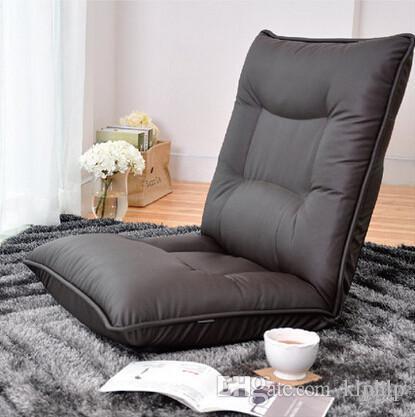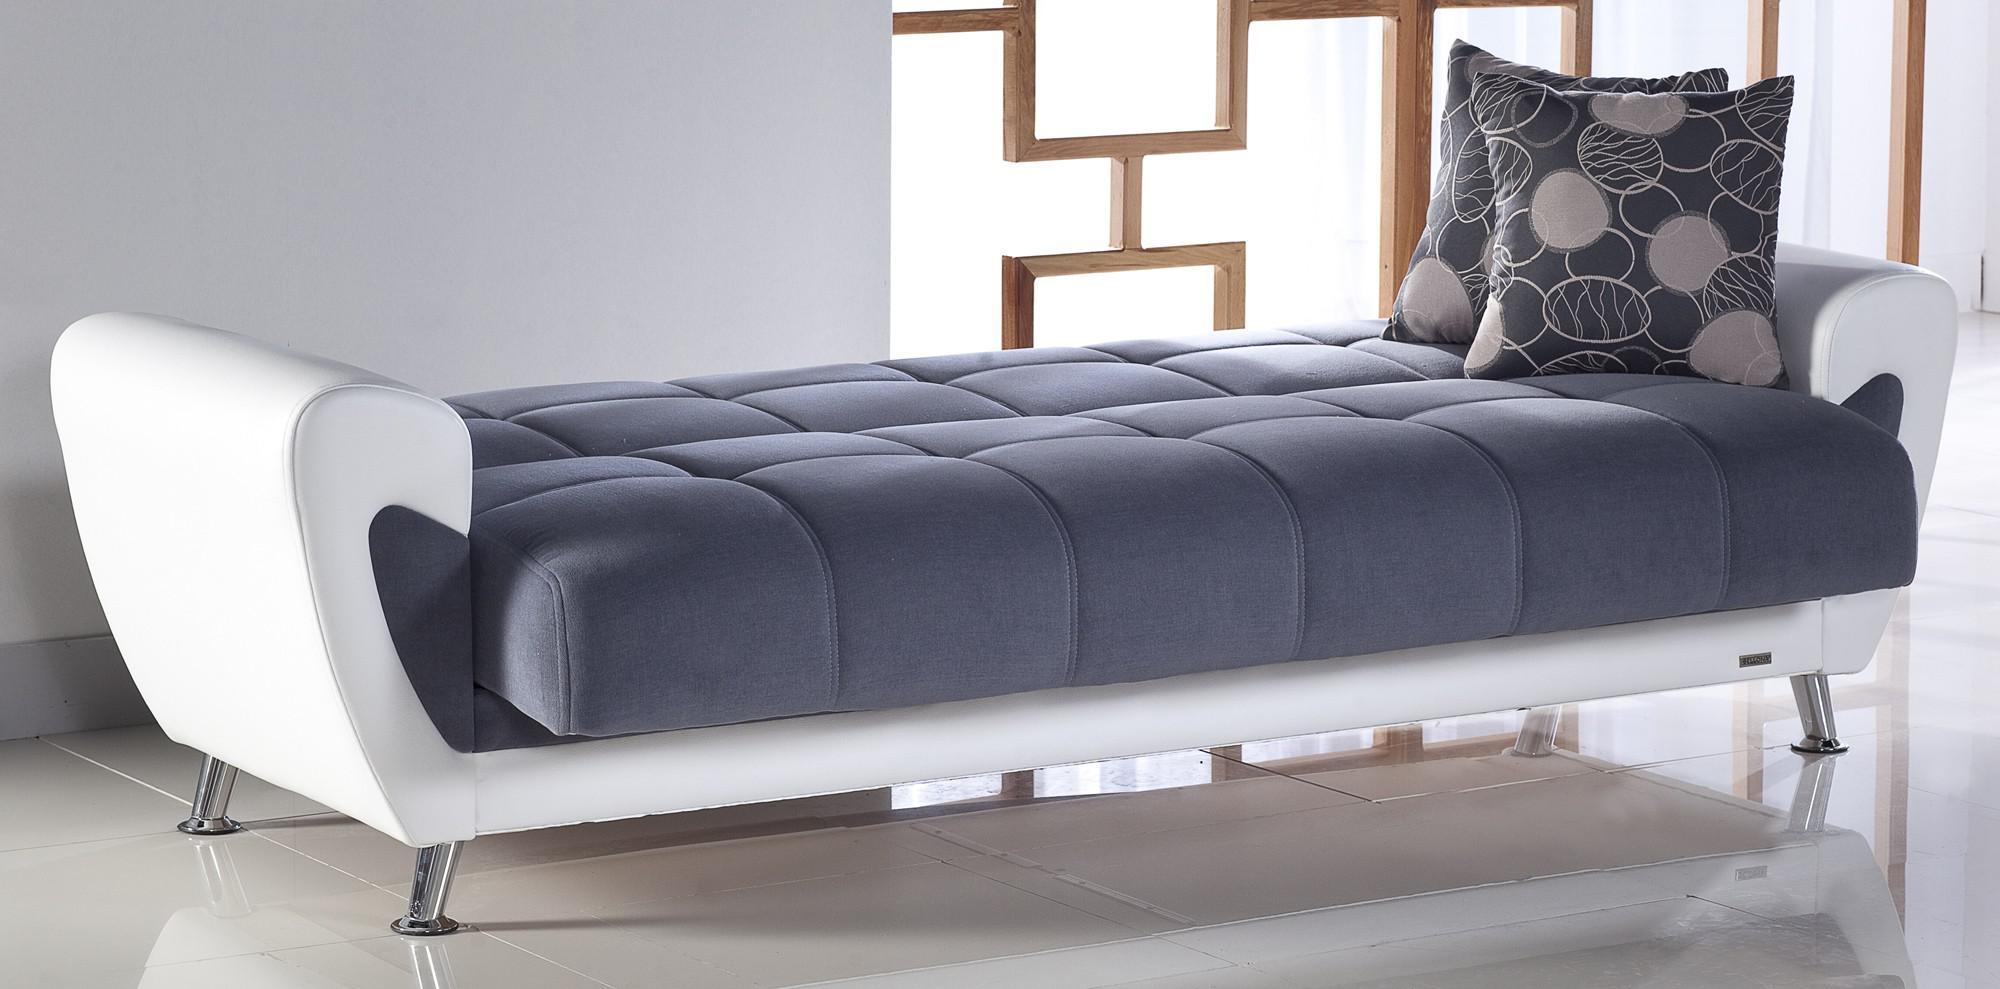The first image is the image on the left, the second image is the image on the right. For the images shown, is this caption "A tufted black cushion sits like a chair without legs and has two black throw pillows on it." true? Answer yes or no. No. The first image is the image on the left, the second image is the image on the right. Evaluate the accuracy of this statement regarding the images: "A solid color loveseat on short legs with two throw pillows is in one image, with the other image showing a wide black tufted floor lounger with two matching pillows.". Is it true? Answer yes or no. No. 